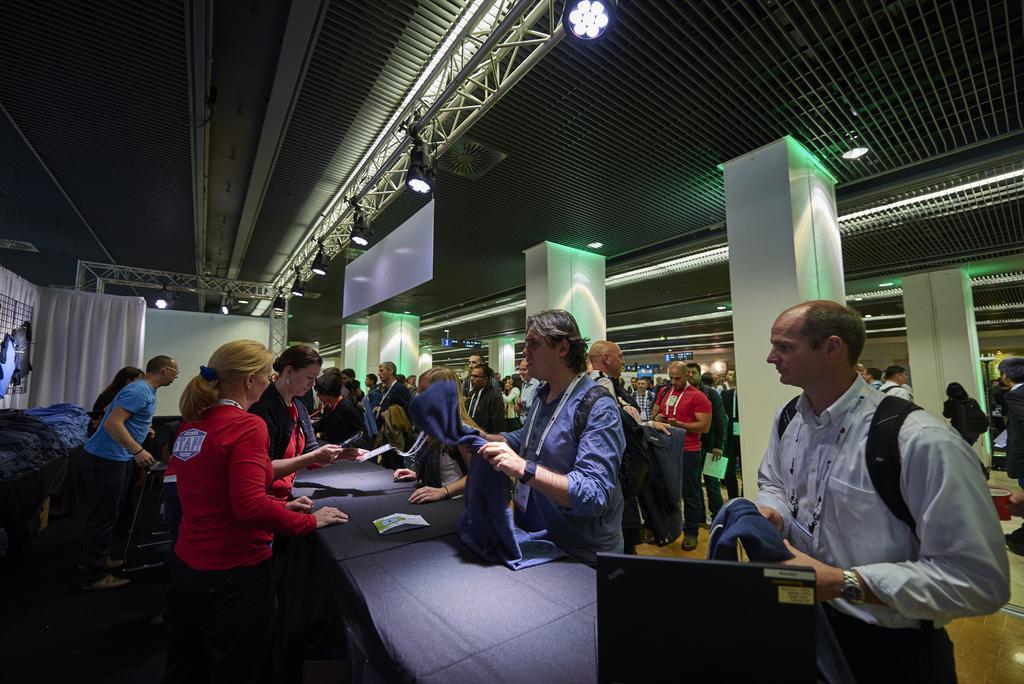How would you summarize this image in a sentence or two? There are group of people standing. These are the pillars. This looks like a white board, which is hanging to the roof. These are the lights and iron pillars. I can see a white cloth hanging. This is the table covered with a cloth. I can see a paper and a black color object on the table. This is the roof. 